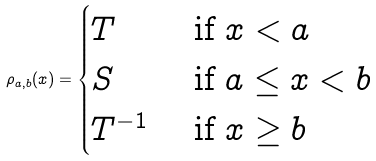<formula> <loc_0><loc_0><loc_500><loc_500>\rho _ { a , b } ( x ) = \begin{cases} T & \text { if } x < a \\ S & \text { if } a \leq x < b \\ T ^ { - 1 } & \text { if } x \geq b \end{cases}</formula> 